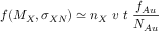<formula> <loc_0><loc_0><loc_500><loc_500>f ( M _ { X } , \sigma _ { X N } ) \simeq n _ { X } \ v \ t \ \frac { f _ { A u } } { N _ { A u } }</formula> 